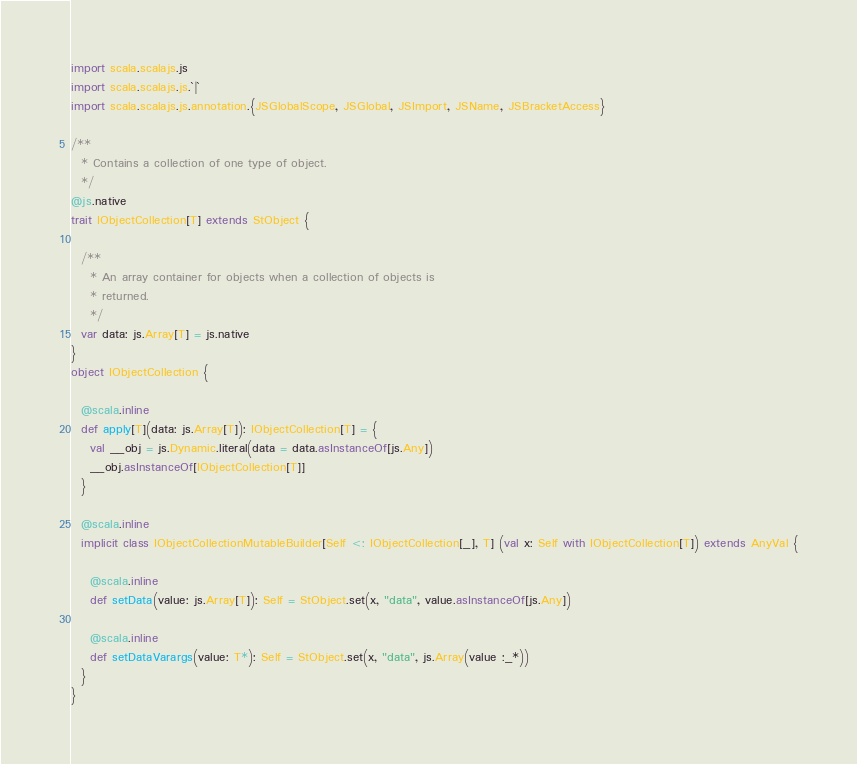<code> <loc_0><loc_0><loc_500><loc_500><_Scala_>import scala.scalajs.js
import scala.scalajs.js.`|`
import scala.scalajs.js.annotation.{JSGlobalScope, JSGlobal, JSImport, JSName, JSBracketAccess}

/**
  * Contains a collection of one type of object.
  */
@js.native
trait IObjectCollection[T] extends StObject {
  
  /**
    * An array container for objects when a collection of objects is
    * returned.
    */
  var data: js.Array[T] = js.native
}
object IObjectCollection {
  
  @scala.inline
  def apply[T](data: js.Array[T]): IObjectCollection[T] = {
    val __obj = js.Dynamic.literal(data = data.asInstanceOf[js.Any])
    __obj.asInstanceOf[IObjectCollection[T]]
  }
  
  @scala.inline
  implicit class IObjectCollectionMutableBuilder[Self <: IObjectCollection[_], T] (val x: Self with IObjectCollection[T]) extends AnyVal {
    
    @scala.inline
    def setData(value: js.Array[T]): Self = StObject.set(x, "data", value.asInstanceOf[js.Any])
    
    @scala.inline
    def setDataVarargs(value: T*): Self = StObject.set(x, "data", js.Array(value :_*))
  }
}
</code> 